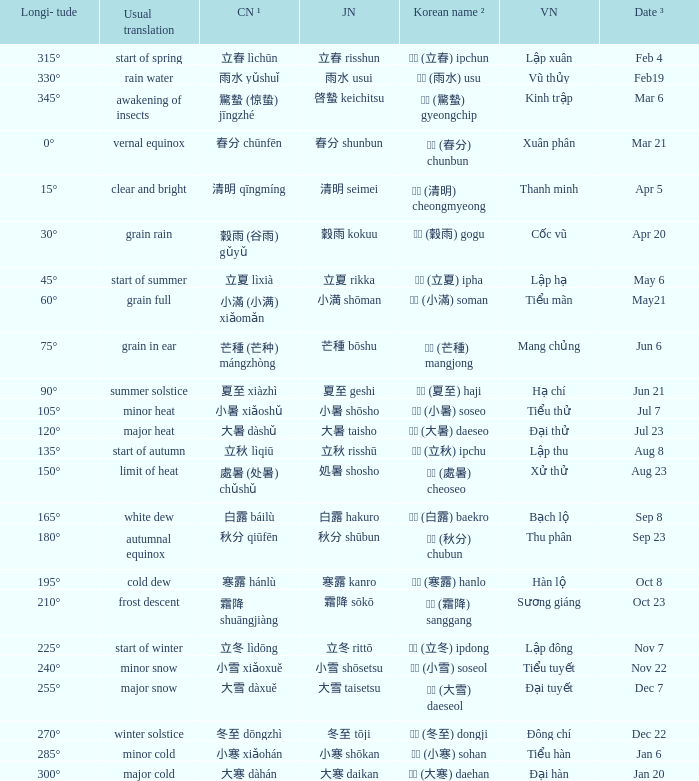When has a Korean name ² of 청명 (清明) cheongmyeong? Apr 5. Could you parse the entire table as a dict? {'header': ['Longi- tude', 'Usual translation', 'CN ¹', 'JN', 'Korean name ²', 'VN', 'Date ³'], 'rows': [['315°', 'start of spring', '立春 lìchūn', '立春 risshun', '입춘 (立春) ipchun', 'Lập xuân', 'Feb 4'], ['330°', 'rain water', '雨水 yǔshuǐ', '雨水 usui', '우수 (雨水) usu', 'Vũ thủy', 'Feb19'], ['345°', 'awakening of insects', '驚蟄 (惊蛰) jīngzhé', '啓蟄 keichitsu', '경칩 (驚蟄) gyeongchip', 'Kinh trập', 'Mar 6'], ['0°', 'vernal equinox', '春分 chūnfēn', '春分 shunbun', '춘분 (春分) chunbun', 'Xuân phân', 'Mar 21'], ['15°', 'clear and bright', '清明 qīngmíng', '清明 seimei', '청명 (清明) cheongmyeong', 'Thanh minh', 'Apr 5'], ['30°', 'grain rain', '穀雨 (谷雨) gǔyǔ', '穀雨 kokuu', '곡우 (穀雨) gogu', 'Cốc vũ', 'Apr 20'], ['45°', 'start of summer', '立夏 lìxià', '立夏 rikka', '입하 (立夏) ipha', 'Lập hạ', 'May 6'], ['60°', 'grain full', '小滿 (小满) xiǎomǎn', '小満 shōman', '소만 (小滿) soman', 'Tiểu mãn', 'May21'], ['75°', 'grain in ear', '芒種 (芒种) mángzhòng', '芒種 bōshu', '망종 (芒種) mangjong', 'Mang chủng', 'Jun 6'], ['90°', 'summer solstice', '夏至 xiàzhì', '夏至 geshi', '하지 (夏至) haji', 'Hạ chí', 'Jun 21'], ['105°', 'minor heat', '小暑 xiǎoshǔ', '小暑 shōsho', '소서 (小暑) soseo', 'Tiểu thử', 'Jul 7'], ['120°', 'major heat', '大暑 dàshǔ', '大暑 taisho', '대서 (大暑) daeseo', 'Đại thử', 'Jul 23'], ['135°', 'start of autumn', '立秋 lìqiū', '立秋 risshū', '입추 (立秋) ipchu', 'Lập thu', 'Aug 8'], ['150°', 'limit of heat', '處暑 (处暑) chǔshǔ', '処暑 shosho', '처서 (處暑) cheoseo', 'Xử thử', 'Aug 23'], ['165°', 'white dew', '白露 báilù', '白露 hakuro', '백로 (白露) baekro', 'Bạch lộ', 'Sep 8'], ['180°', 'autumnal equinox', '秋分 qiūfēn', '秋分 shūbun', '추분 (秋分) chubun', 'Thu phân', 'Sep 23'], ['195°', 'cold dew', '寒露 hánlù', '寒露 kanro', '한로 (寒露) hanlo', 'Hàn lộ', 'Oct 8'], ['210°', 'frost descent', '霜降 shuāngjiàng', '霜降 sōkō', '상강 (霜降) sanggang', 'Sương giáng', 'Oct 23'], ['225°', 'start of winter', '立冬 lìdōng', '立冬 rittō', '입동 (立冬) ipdong', 'Lập đông', 'Nov 7'], ['240°', 'minor snow', '小雪 xiǎoxuě', '小雪 shōsetsu', '소설 (小雪) soseol', 'Tiểu tuyết', 'Nov 22'], ['255°', 'major snow', '大雪 dàxuě', '大雪 taisetsu', '대설 (大雪) daeseol', 'Đại tuyết', 'Dec 7'], ['270°', 'winter solstice', '冬至 dōngzhì', '冬至 tōji', '동지 (冬至) dongji', 'Đông chí', 'Dec 22'], ['285°', 'minor cold', '小寒 xiǎohán', '小寒 shōkan', '소한 (小寒) sohan', 'Tiểu hàn', 'Jan 6'], ['300°', 'major cold', '大寒 dàhán', '大寒 daikan', '대한 (大寒) daehan', 'Đại hàn', 'Jan 20']]} 